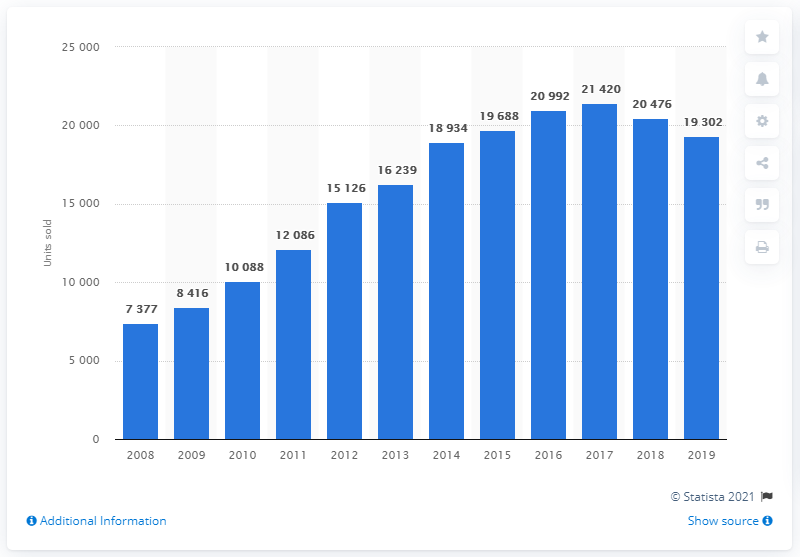Give some essential details in this illustration. In 2017, a total of 20992 Hyundai cars were sold in the Czech Republic. In 2019, a total of 19,302 Hyundai cars were sold in the Czech Republic. 